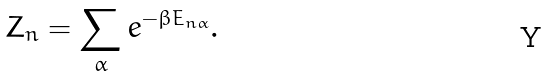<formula> <loc_0><loc_0><loc_500><loc_500>Z _ { n } = \sum _ { \alpha } e ^ { - \beta E _ { n \alpha } } .</formula> 